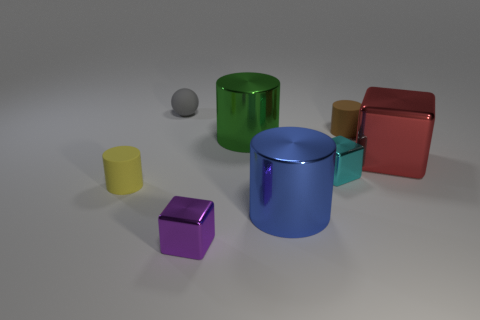Add 1 red metallic objects. How many objects exist? 9 Subtract all red cylinders. Subtract all green blocks. How many cylinders are left? 4 Subtract all spheres. How many objects are left? 7 Add 8 small gray objects. How many small gray objects are left? 9 Add 7 big shiny cylinders. How many big shiny cylinders exist? 9 Subtract 0 gray blocks. How many objects are left? 8 Subtract all gray rubber spheres. Subtract all cyan shiny things. How many objects are left? 6 